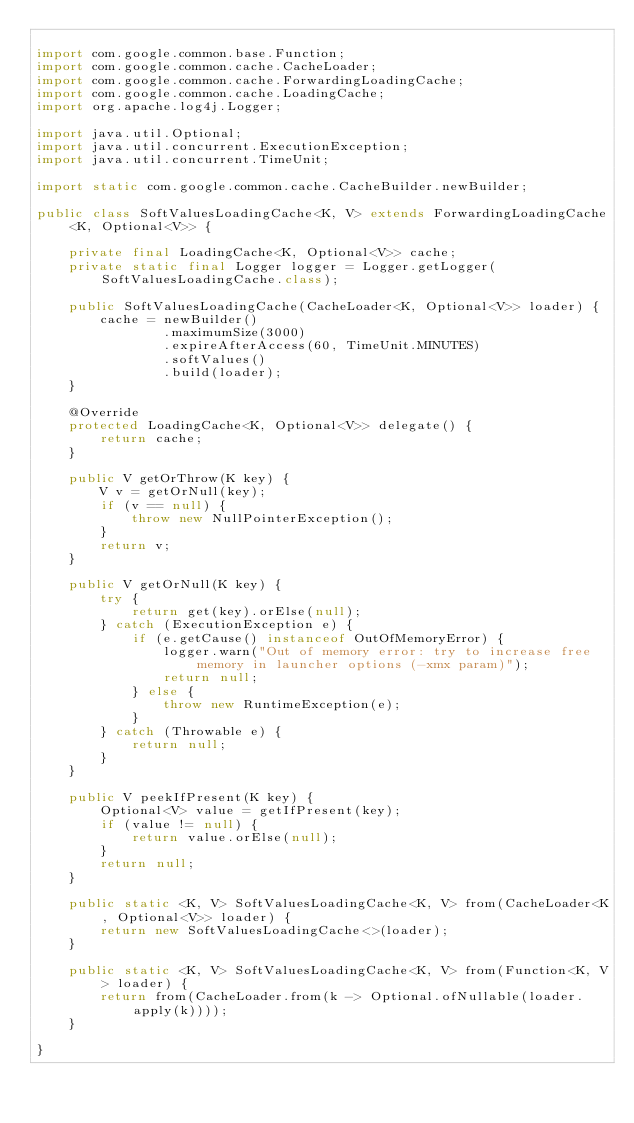<code> <loc_0><loc_0><loc_500><loc_500><_Java_>
import com.google.common.base.Function;
import com.google.common.cache.CacheLoader;
import com.google.common.cache.ForwardingLoadingCache;
import com.google.common.cache.LoadingCache;
import org.apache.log4j.Logger;

import java.util.Optional;
import java.util.concurrent.ExecutionException;
import java.util.concurrent.TimeUnit;

import static com.google.common.cache.CacheBuilder.newBuilder;

public class SoftValuesLoadingCache<K, V> extends ForwardingLoadingCache<K, Optional<V>> {

    private final LoadingCache<K, Optional<V>> cache;
    private static final Logger logger = Logger.getLogger(SoftValuesLoadingCache.class);

    public SoftValuesLoadingCache(CacheLoader<K, Optional<V>> loader) {
        cache = newBuilder()
                .maximumSize(3000)
                .expireAfterAccess(60, TimeUnit.MINUTES)
                .softValues()
                .build(loader);
    }

    @Override
    protected LoadingCache<K, Optional<V>> delegate() {
        return cache;
    }

    public V getOrThrow(K key) {
        V v = getOrNull(key);
        if (v == null) {
            throw new NullPointerException();
        }
        return v;
    }

    public V getOrNull(K key) {
        try {
            return get(key).orElse(null);
        } catch (ExecutionException e) {
            if (e.getCause() instanceof OutOfMemoryError) {
                logger.warn("Out of memory error: try to increase free memory in launcher options (-xmx param)");
                return null;
            } else {
                throw new RuntimeException(e);
            }
        } catch (Throwable e) {
            return null;
        }
    }

    public V peekIfPresent(K key) {
        Optional<V> value = getIfPresent(key);
        if (value != null) {
            return value.orElse(null);
        }
        return null;
    }

    public static <K, V> SoftValuesLoadingCache<K, V> from(CacheLoader<K, Optional<V>> loader) {
        return new SoftValuesLoadingCache<>(loader);
    }

    public static <K, V> SoftValuesLoadingCache<K, V> from(Function<K, V> loader) {
        return from(CacheLoader.from(k -> Optional.ofNullable(loader.apply(k))));
    }

}
</code> 